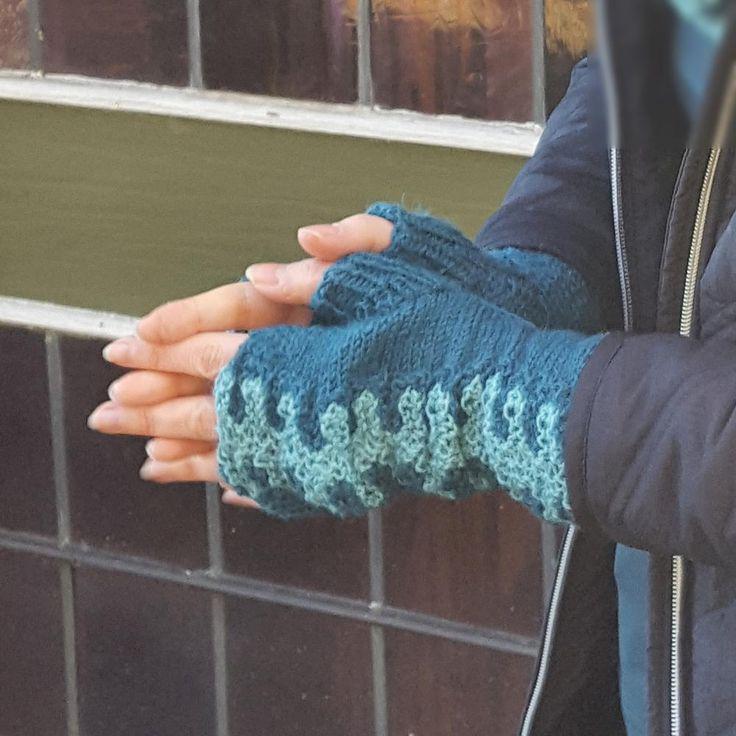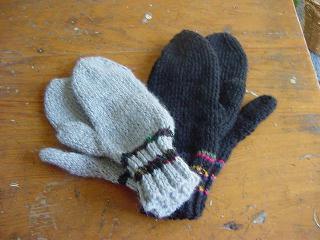The first image is the image on the left, the second image is the image on the right. For the images shown, is this caption "The left image contains a human wearing blue gloves that have the finger tips cut off." true? Answer yes or no. Yes. The first image is the image on the left, the second image is the image on the right. For the images shown, is this caption "A pair of gloves is being worn on a set of hands in the image on the left." true? Answer yes or no. Yes. 